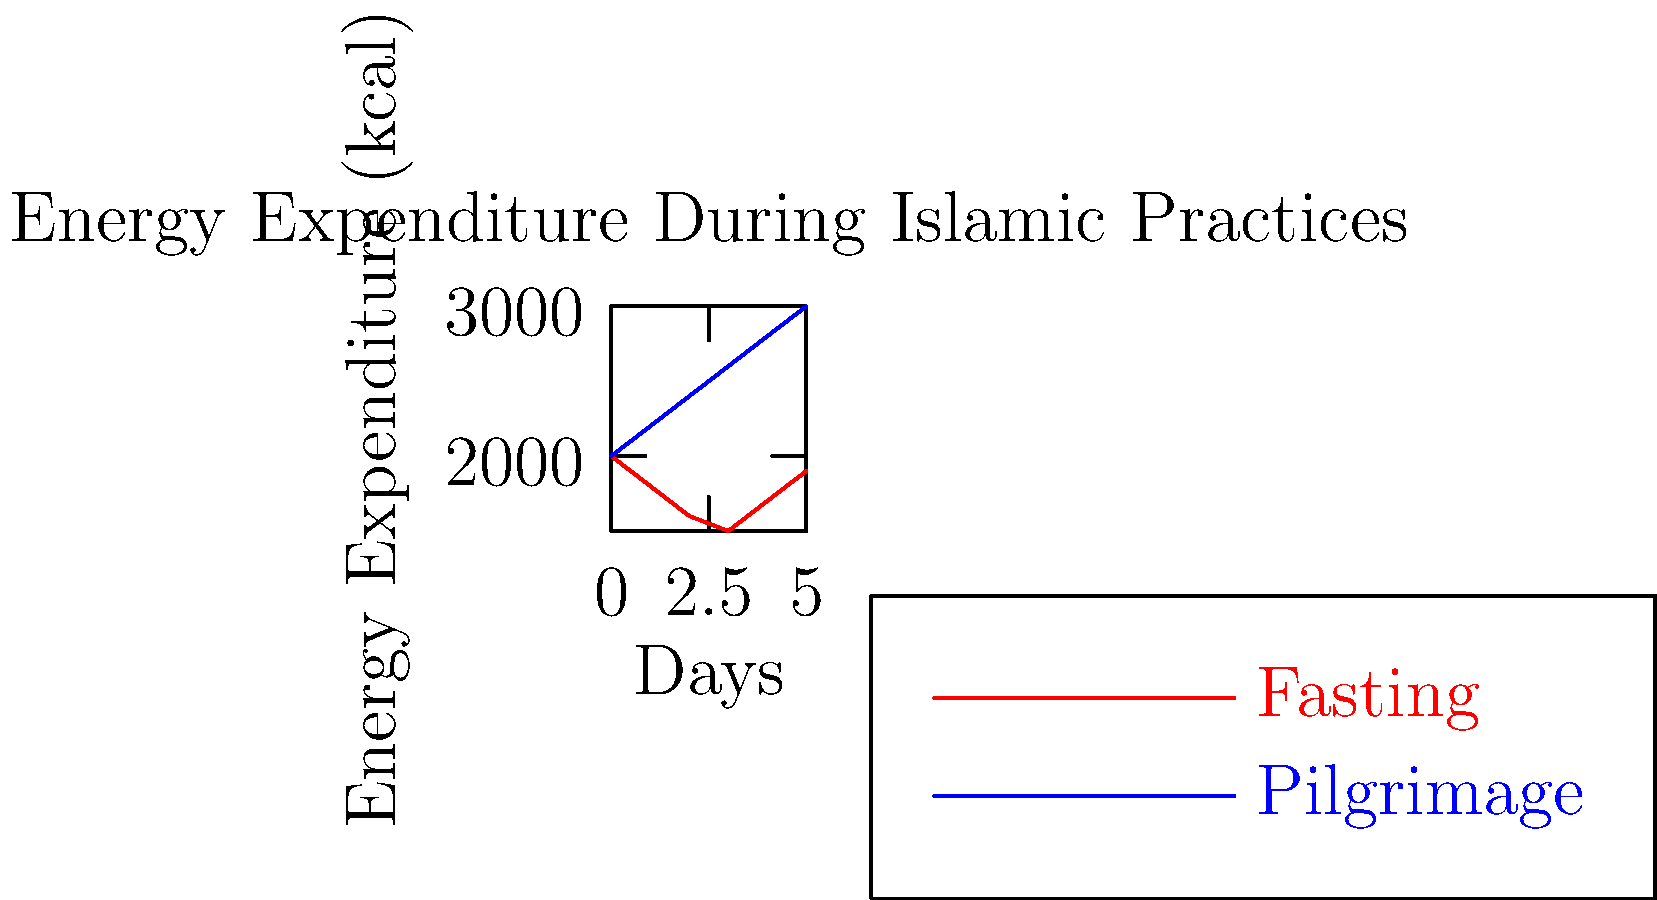Based on the graph showing energy expenditure during Islamic practices, calculate the difference in total energy expenditure over the 5-day period between fasting and pilgrimage. How might this information be relevant to your experiences in the Muslim community? To solve this problem, we need to follow these steps:

1. Calculate the total energy expenditure for fasting:
   Day 0: 2000 kcal
   Day 1: 1800 kcal
   Day 2: 1600 kcal
   Day 3: 1500 kcal
   Day 4: 1700 kcal
   Day 5: 1900 kcal
   Total = 2000 + 1800 + 1600 + 1500 + 1700 + 1900 = 10,500 kcal

2. Calculate the total energy expenditure for pilgrimage:
   Day 0: 2000 kcal
   Day 1: 2200 kcal
   Day 2: 2400 kcal
   Day 3: 2600 kcal
   Day 4: 2800 kcal
   Day 5: 3000 kcal
   Total = 2000 + 2200 + 2400 + 2600 + 2800 + 3000 = 15,000 kcal

3. Calculate the difference:
   Difference = Pilgrimage total - Fasting total
               = 15,000 - 10,500 = 4,500 kcal

This information is relevant to the Muslim community as it highlights the physiological demands of different Islamic practices. Fasting during Ramadan results in lower energy expenditure, which aligns with the practice of conserving energy and focusing on spiritual reflection. In contrast, the pilgrimage (Hajj) shows increasing energy expenditure, reflecting the physical demands of the journey and rituals involved.

Understanding these differences can help community members prepare for these practices, especially those with health concerns or specific dietary needs. It can also inform community support systems, such as organizing appropriate meals for breaking fasts or preparing pilgrims for the physical challenges of Hajj.
Answer: 4,500 kcal 